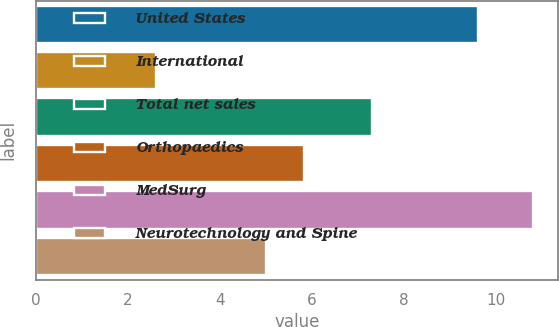<chart> <loc_0><loc_0><loc_500><loc_500><bar_chart><fcel>United States<fcel>International<fcel>Total net sales<fcel>Orthopaedics<fcel>MedSurg<fcel>Neurotechnology and Spine<nl><fcel>9.6<fcel>2.6<fcel>7.3<fcel>5.82<fcel>10.8<fcel>5<nl></chart> 